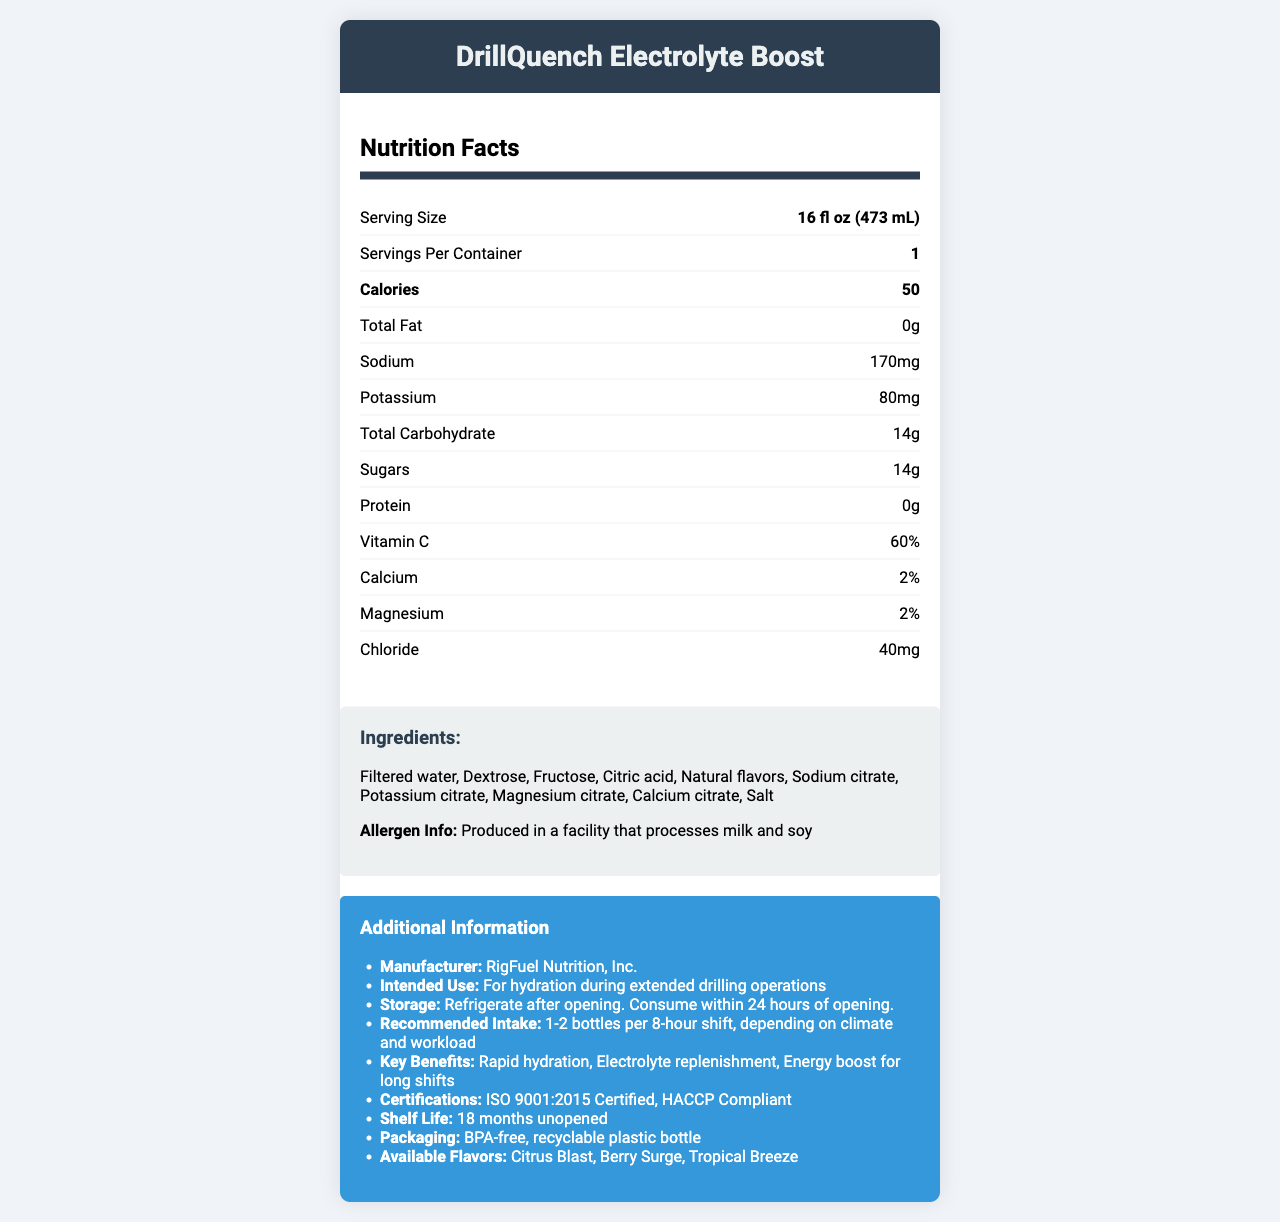what is the serving size for DrillQuench Electrolyte Boost? The serving size is listed under the section "Nutrition Facts" as 16 fl oz (473 mL).
Answer: 16 fl oz (473 mL) how many calories are in one serving? The number of calories is shown in the Nutrition Facts section as 50.
Answer: 50 what is the sodium content for one serving? The sodium content is specified under the Nutrition Facts section with a value of 170 mg.
Answer: 170 mg what is the potassium content per serving? The potassium content is provided in the Nutrition Facts section with a value of 80 mg.
Answer: 80 mg how much sugar does DrillQuench Electrolyte Boost contain per serving? The amount of sugars per serving is listed as 14 g in the Nutrition Facts section.
Answer: 14 g which of the following is an ingredient in DrillQuench Electrolyte Boost? A. High fructose corn syrup B. Cane sugar C. Fructose D. Sucralose The list of ingredients includes fructose. High fructose corn syrup, cane sugar, and sucralose are not listed.
Answer: C what are the available flavors for DrillQuench Electrolyte Boost? A. Citrus Blast, Berry Surge, Tropical Breeze B. Lemon Lime, Orange, Grape C. Cranberry, Raspberry, Pineapple The document lists the available flavors as Citrus Blast, Berry Surge, and Tropical Breeze.
Answer: A is DrillQuench Electrolyte Boost ISO 9001:2015 Certified? The document lists ISO 9001:2015 Certification under the "Certifications" section.
Answer: Yes summarize the key benefits of DrillQuench Electrolyte Boost. The key benefits are clearly listed in the "additional info" section.
Answer: Rapid hydration, Electrolyte replenishment, Energy boost for long shifts how long is the shelf life of DrillQuench Electrolyte Boost when unopened? The shelf life is specified as 18 months unopened in the additional information section.
Answer: 18 months what is the recommended intake for DrillQuench Electrolyte Boost during an 8-hour shift? The recommended intake is listed under "recommended intake" as 1-2 bottles per 8-hour shift.
Answer: 1-2 bottles per 8-hour shift, depending on climate and workload what percent daily value of Vitamin C does one serving provide? The document indicates that one serving provides 60% of the daily value for Vitamin C in the Nutrition Facts section.
Answer: 60% what storage instructions are provided for DrillQuench Electrolyte Boost after opening? The storage instructions state that the product should be refrigerated after opening and consumed within 24 hours.
Answer: Refrigerate after opening. Consume within 24 hours of opening. what is the total carbohydrate content per serving? The total carbohydrate content per serving is 14 g, as mentioned in the Nutrition Facts section.
Answer: 14 g what is the name of the manufacturer? The name of the manufacturer is listed under additional information as RigFuel Nutrition, Inc.
Answer: RigFuel Nutrition, Inc. are there any soy allergens in DrillQuench Electrolyte Boost? The document states that it is produced in a facility that processes milk and soy, but it does not explicitly state if the product itself contains soy allergens.
Answer: Not enough information 